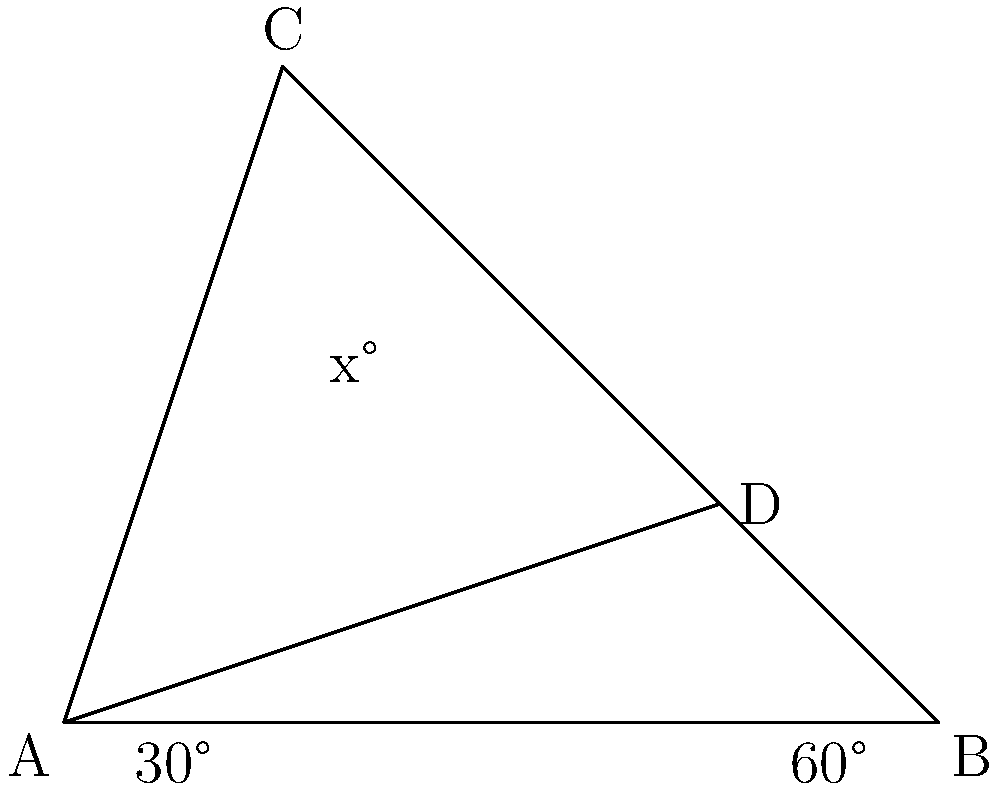On your TV show set, you're discussing a geometric design element. Two intersecting lines form a triangle ABC with line AD inside. If angle BAD is 30° and angle ABD is 60°, what is the measure of angle CAD (represented by x° in the diagram)? Let's approach this step-by-step:

1) First, recall that the sum of angles in a triangle is always 180°.

2) In triangle ABC, we know two angles:
   - Angle BAC = 30°
   - Angle ABC = 60°

3) Let's call the unknown angle BCA as y°. We can find y using the triangle angle sum property:
   $30° + 60° + y° = 180°$
   $y° = 180° - 90° = 90°$

4) Now, we have a right angle at C (90°).

5) The line AD creates two angles that sum to 90° (the right angle at C):
   $x° + (90° - x°) = 90°$

6) We're given that angle BAD is 30°. This means that:
   $90° - x° = 30°$

7) Solving for x:
   $90° - 30° = x°$
   $60° = x°$

Therefore, angle CAD (x°) measures 60°.
Answer: 60° 